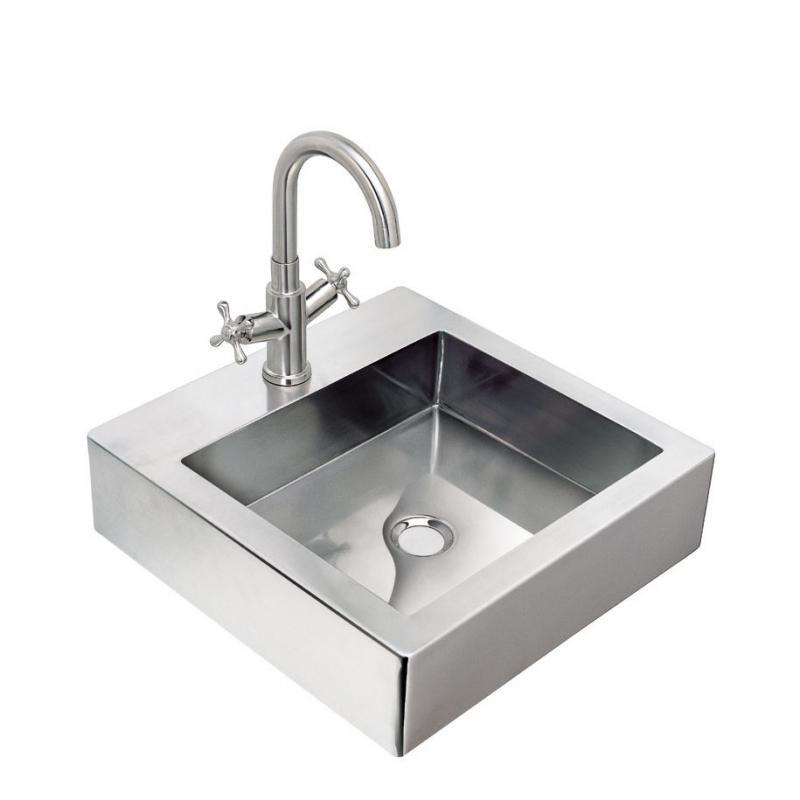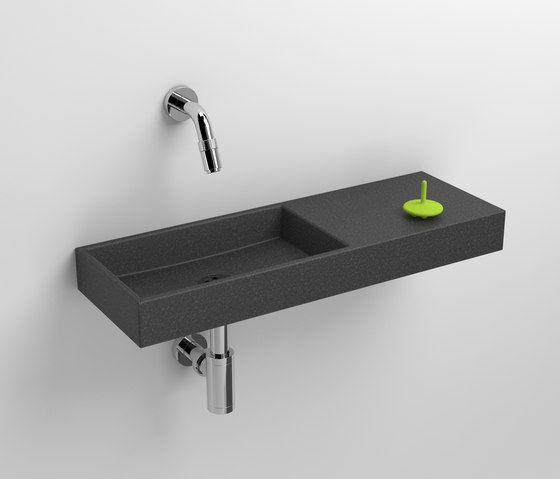The first image is the image on the left, the second image is the image on the right. For the images displayed, is the sentence "An image features a wall-mounted semi-circle white sinkwith chrome dispenser on top." factually correct? Answer yes or no. No. The first image is the image on the left, the second image is the image on the right. Analyze the images presented: Is the assertion "There is one oval shaped sink and one rectangle shaped sink attached to the wall." valid? Answer yes or no. No. 